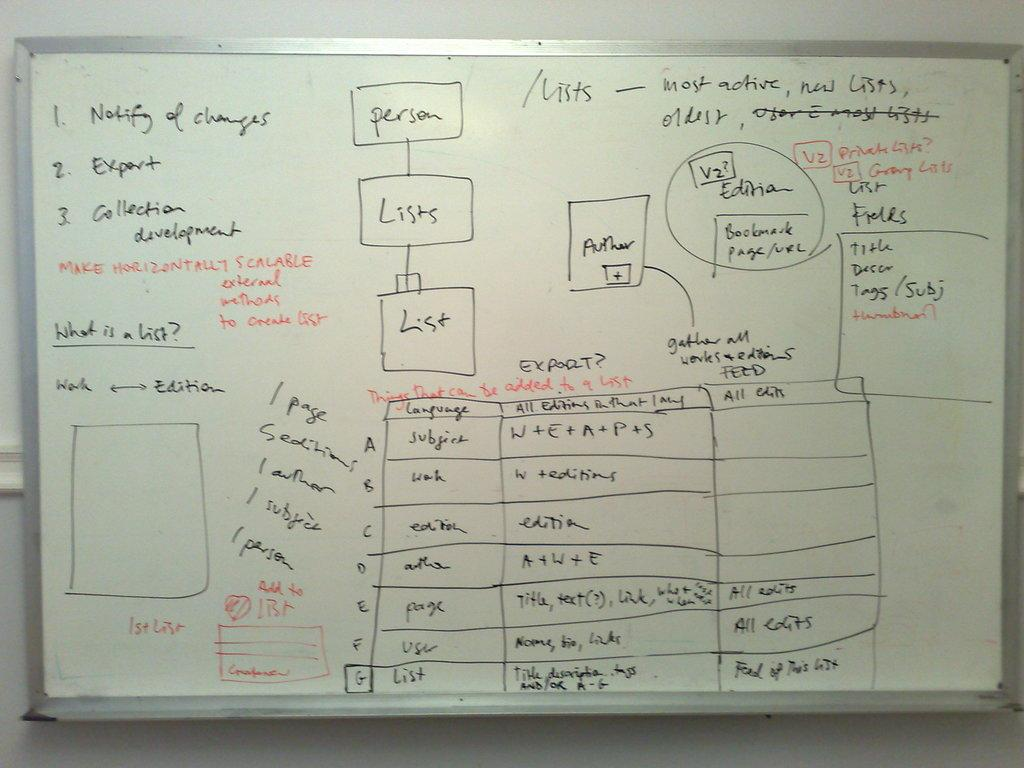<image>
Give a short and clear explanation of the subsequent image. The first bullet point on the left says Notify of Changes 